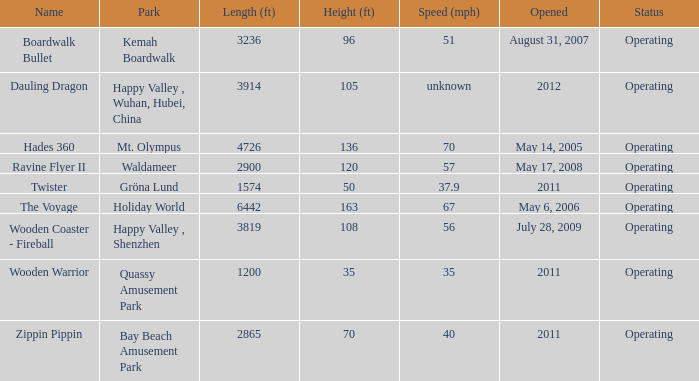What is the length of the coaster with the unknown speed 3914.0. Give me the full table as a dictionary. {'header': ['Name', 'Park', 'Length (ft)', 'Height (ft)', 'Speed (mph)', 'Opened', 'Status'], 'rows': [['Boardwalk Bullet', 'Kemah Boardwalk', '3236', '96', '51', 'August 31, 2007', 'Operating'], ['Dauling Dragon', 'Happy Valley , Wuhan, Hubei, China', '3914', '105', 'unknown', '2012', 'Operating'], ['Hades 360', 'Mt. Olympus', '4726', '136', '70', 'May 14, 2005', 'Operating'], ['Ravine Flyer II', 'Waldameer', '2900', '120', '57', 'May 17, 2008', 'Operating'], ['Twister', 'Gröna Lund', '1574', '50', '37.9', '2011', 'Operating'], ['The Voyage', 'Holiday World', '6442', '163', '67', 'May 6, 2006', 'Operating'], ['Wooden Coaster - Fireball', 'Happy Valley , Shenzhen', '3819', '108', '56', 'July 28, 2009', 'Operating'], ['Wooden Warrior', 'Quassy Amusement Park', '1200', '35', '35', '2011', 'Operating'], ['Zippin Pippin', 'Bay Beach Amusement Park', '2865', '70', '40', '2011', 'Operating']]} 